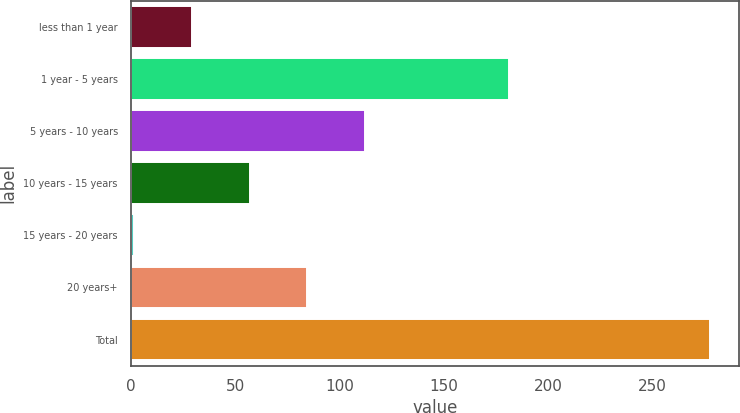Convert chart. <chart><loc_0><loc_0><loc_500><loc_500><bar_chart><fcel>less than 1 year<fcel>1 year - 5 years<fcel>5 years - 10 years<fcel>10 years - 15 years<fcel>15 years - 20 years<fcel>20 years+<fcel>Total<nl><fcel>29.22<fcel>181.2<fcel>112.08<fcel>56.84<fcel>1.6<fcel>84.46<fcel>277.8<nl></chart> 